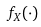Convert formula to latex. <formula><loc_0><loc_0><loc_500><loc_500>f _ { X } ( \cdot )</formula> 